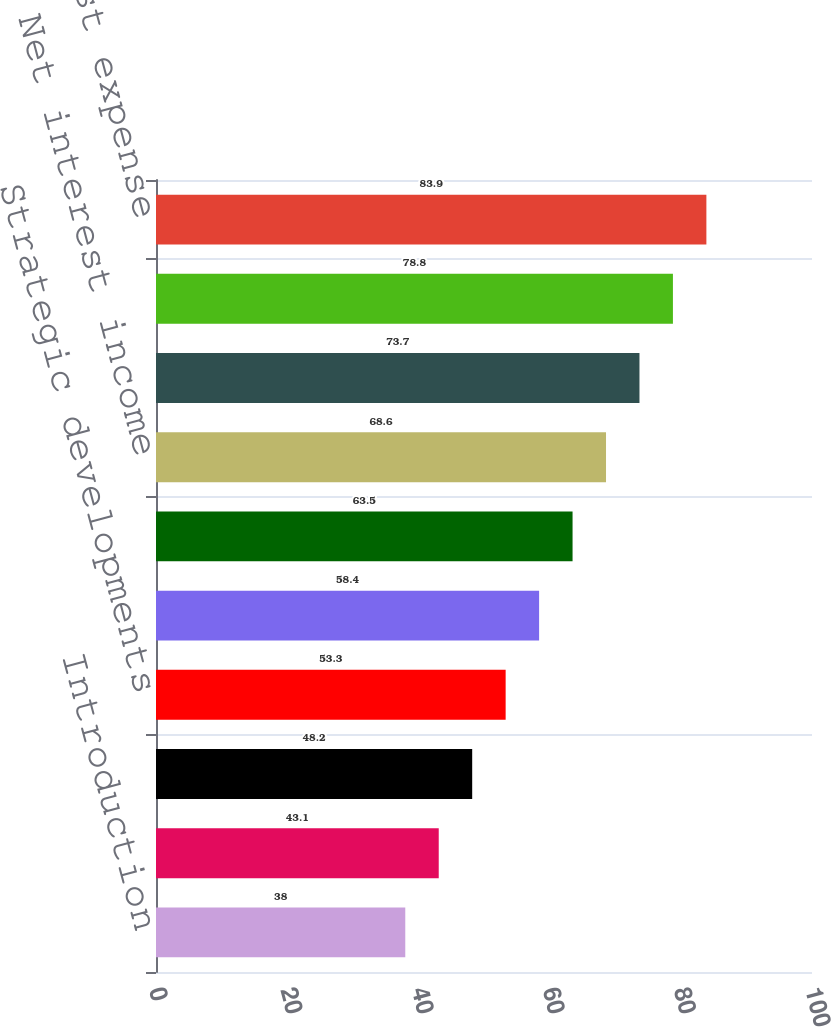<chart> <loc_0><loc_0><loc_500><loc_500><bar_chart><fcel>Introduction<fcel>Long-term financial targets<fcel>Corporate strategy<fcel>Strategic developments<fcel>Results of Operations<fcel>Earnings overview<fcel>Net interest income<fcel>Provision for credit losses<fcel>Noninterest income<fcel>Noninterest expense<nl><fcel>38<fcel>43.1<fcel>48.2<fcel>53.3<fcel>58.4<fcel>63.5<fcel>68.6<fcel>73.7<fcel>78.8<fcel>83.9<nl></chart> 